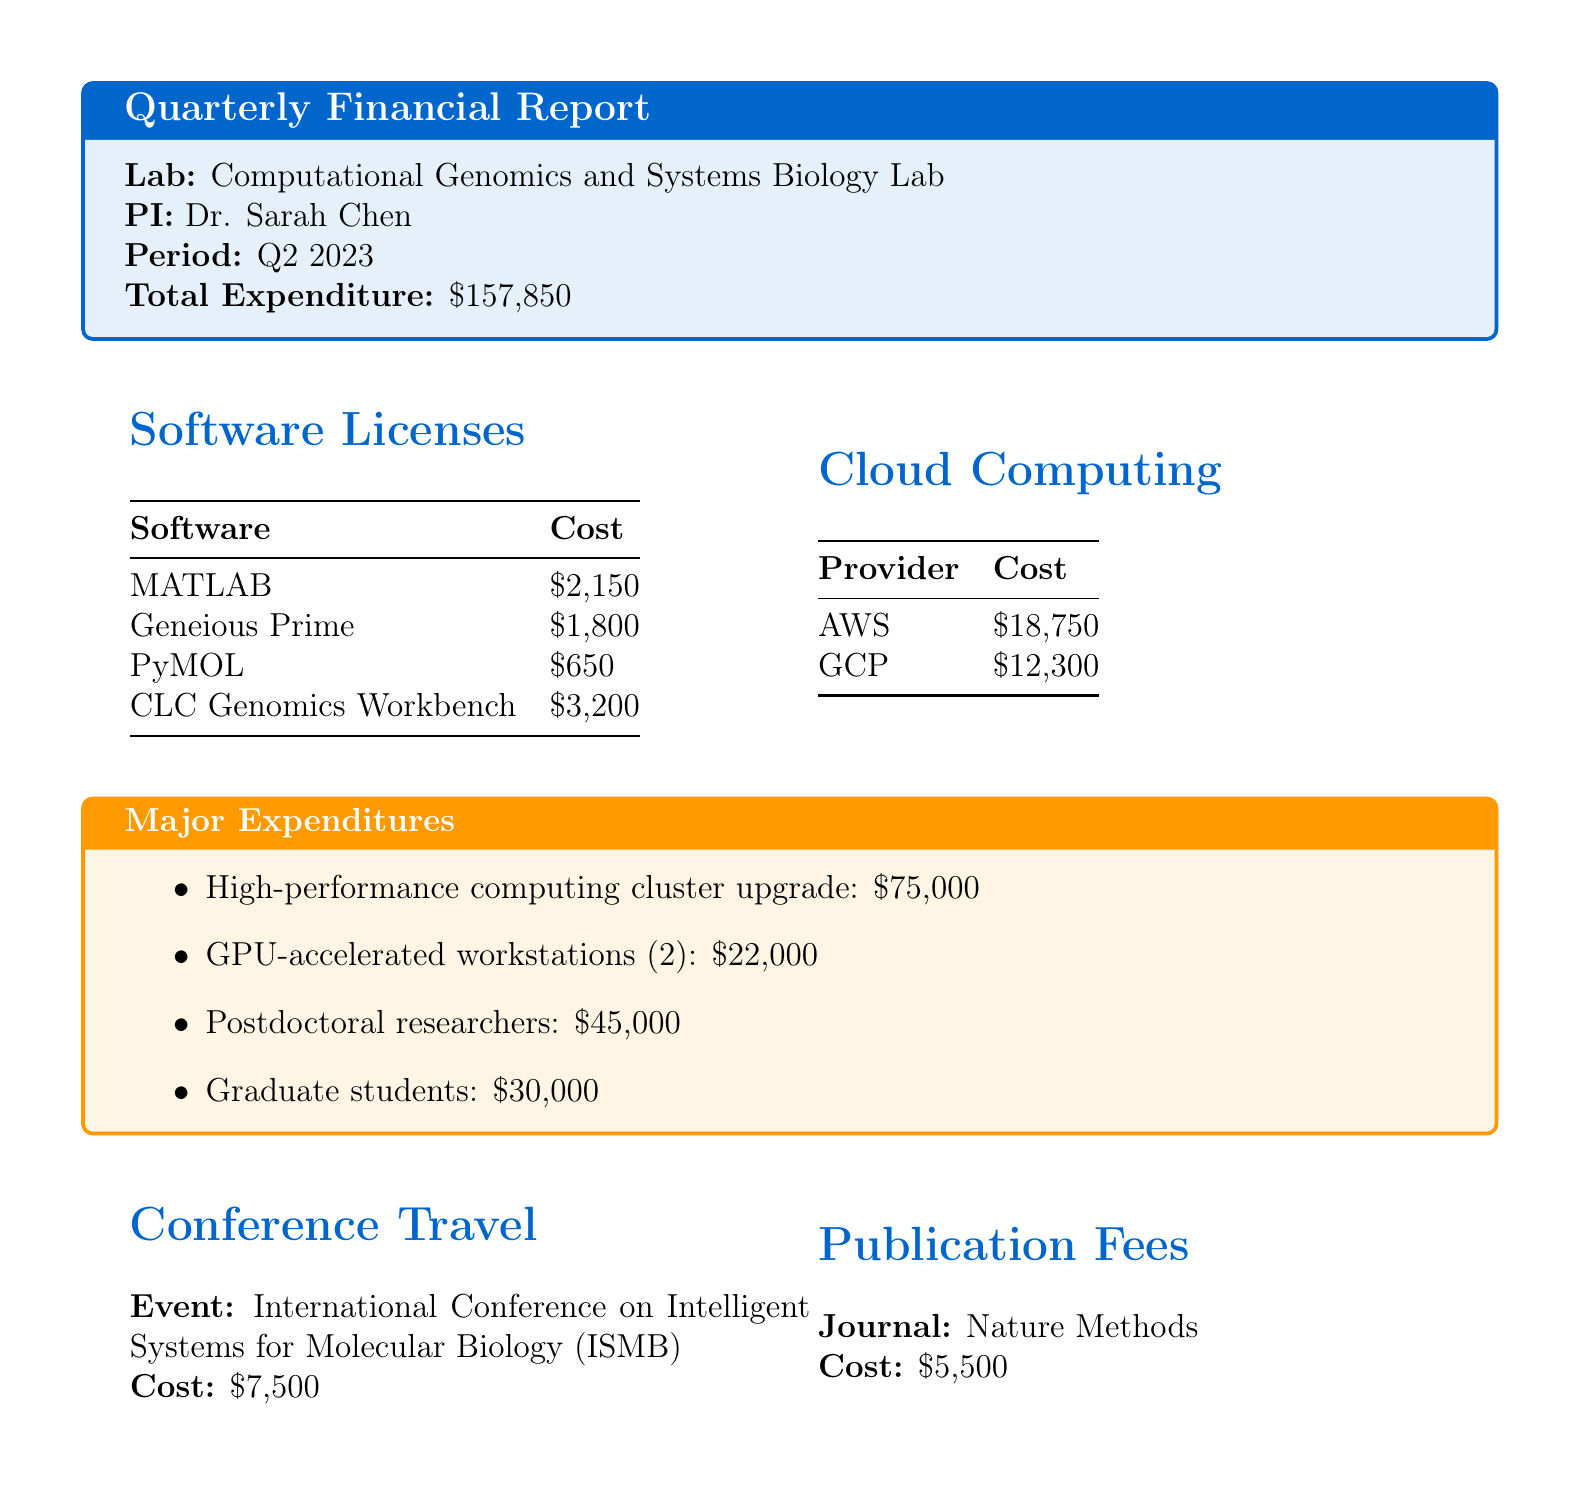What is the name of the lab? The name of the lab is provided in the document's introductory section.
Answer: Computational Genomics and Systems Biology Lab Who is the principal investigator? The principal investigator is specifically stated in the document.
Answer: Dr. Sarah Chen What is the total grant expenditure for Q2 2023? The total expenditure amount is mentioned explicitly in the document.
Answer: $157,850 How much was spent on cloud computing costs? The sum of the costs for AWS and GCP services gives the total for cloud computing. The costs are $18,750 + $12,300.
Answer: $31,050 What is the cost of MATLAB? MATLAB's cost is listed in the software licenses section of the document.
Answer: $2,150 What is the major purchase related to high-performance computing? The specific item related to high-performance computing is detailed under major expenditures.
Answer: High-performance computing cluster upgrade What was the cost for conference travel? The cost associated with the conference event is stated clearly in the document.
Answer: $7,500 Which journal was mentioned for publication fees? The document specifies the journal associated with the publication fees.
Answer: Nature Methods What is the combined cost of postdoctoral researchers and graduate students? This requires adding the two specified personnel costs for an accurate total.
Answer: $75,000 